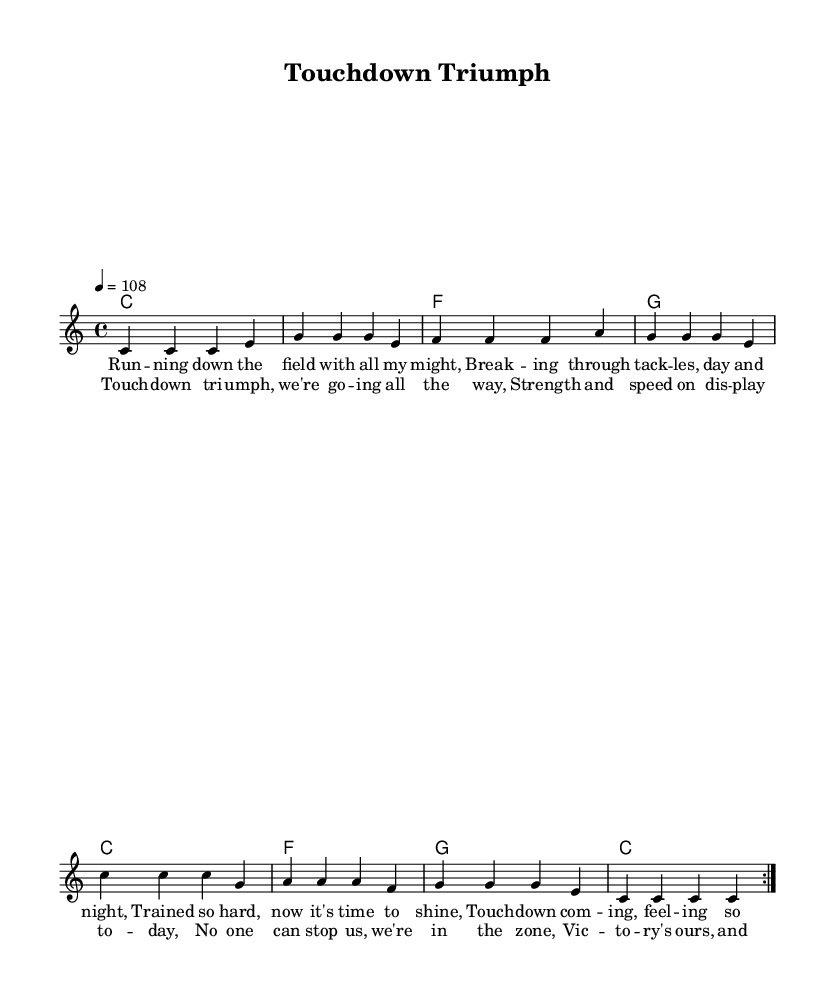What is the key signature of this music? The key signature is C major, which has no sharps or flats indicated on the staff.
Answer: C major What is the time signature of the piece? The time signature is 4/4, meaning there are four beats per measure and a quarter note receives one beat.
Answer: 4/4 What is the tempo marking of the composition? The tempo marking indicates a speed of 108 beats per minute, as indicated at the beginning of the score.
Answer: 108 How many measures are in the verse section before the chorus? The verse consists of 8 measures, with the lyrics indicating lines that span two measures each for a total of four lines.
Answer: 8 Which chord follows the C major chord in the harmonies? The next chord after the C major chord in the progression is F major, as per the sequence shown in the harmonies.
Answer: F What type of mood does this reggae piece convey? The piece conveys an upbeat and celebratory mood that resonates with themes of athletic success and physical strength.
Answer: Upbeat What repeating structure is observed in the melody? The melody has a repeating structure where the first section is repeated twice, known as a volta, which enhances its catchiness typical of reggae music.
Answer: Repeat 